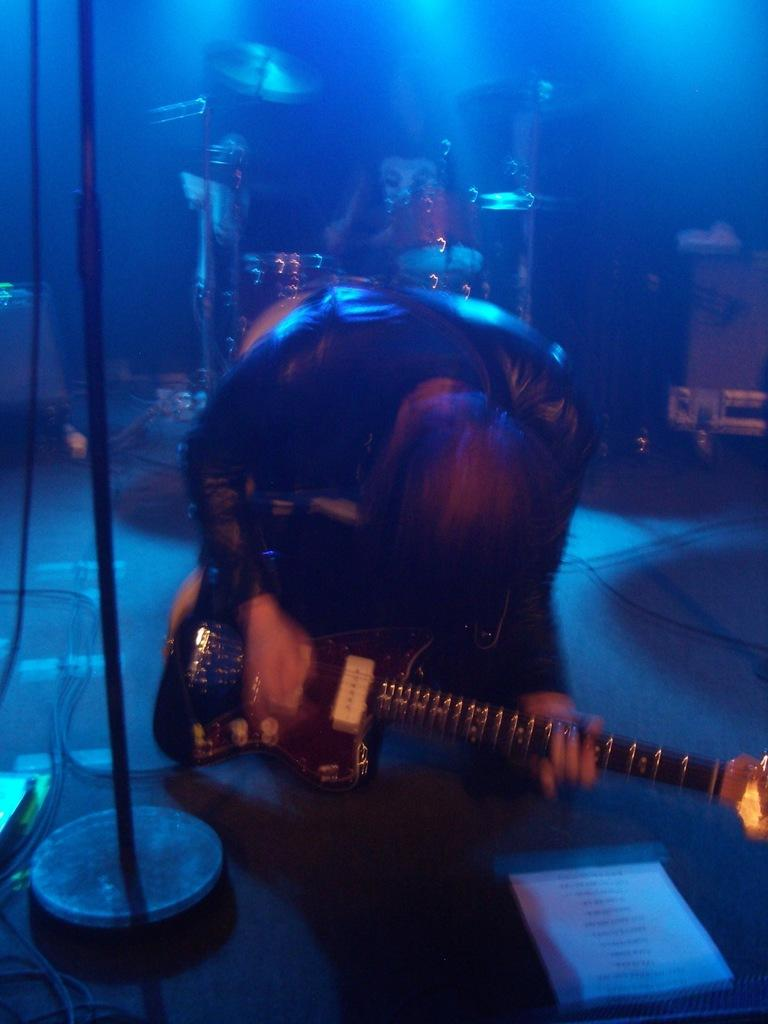What is the person in the image doing? The person is playing a guitar. Can you describe any objects in the image besides the guitar? Yes, there is a stand in the image. What color is the background of the image? The background color is blue. What other musical instrument can be seen in the image? There is a drum in the background. What type of sign can be seen in the image? There is no sign present in the image. Is there any spark visible in the image? There is no spark visible in the image. 